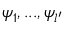<formula> <loc_0><loc_0><loc_500><loc_500>\psi _ { 1 } , \dots , \psi _ { l ^ { \prime } }</formula> 